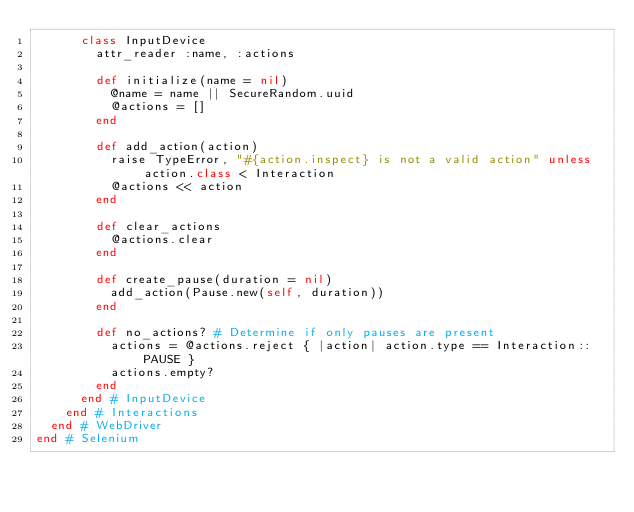Convert code to text. <code><loc_0><loc_0><loc_500><loc_500><_Ruby_>      class InputDevice
        attr_reader :name, :actions

        def initialize(name = nil)
          @name = name || SecureRandom.uuid
          @actions = []
        end

        def add_action(action)
          raise TypeError, "#{action.inspect} is not a valid action" unless action.class < Interaction
          @actions << action
        end

        def clear_actions
          @actions.clear
        end

        def create_pause(duration = nil)
          add_action(Pause.new(self, duration))
        end

        def no_actions? # Determine if only pauses are present
          actions = @actions.reject { |action| action.type == Interaction::PAUSE }
          actions.empty?
        end
      end # InputDevice
    end # Interactions
  end # WebDriver
end # Selenium
</code> 